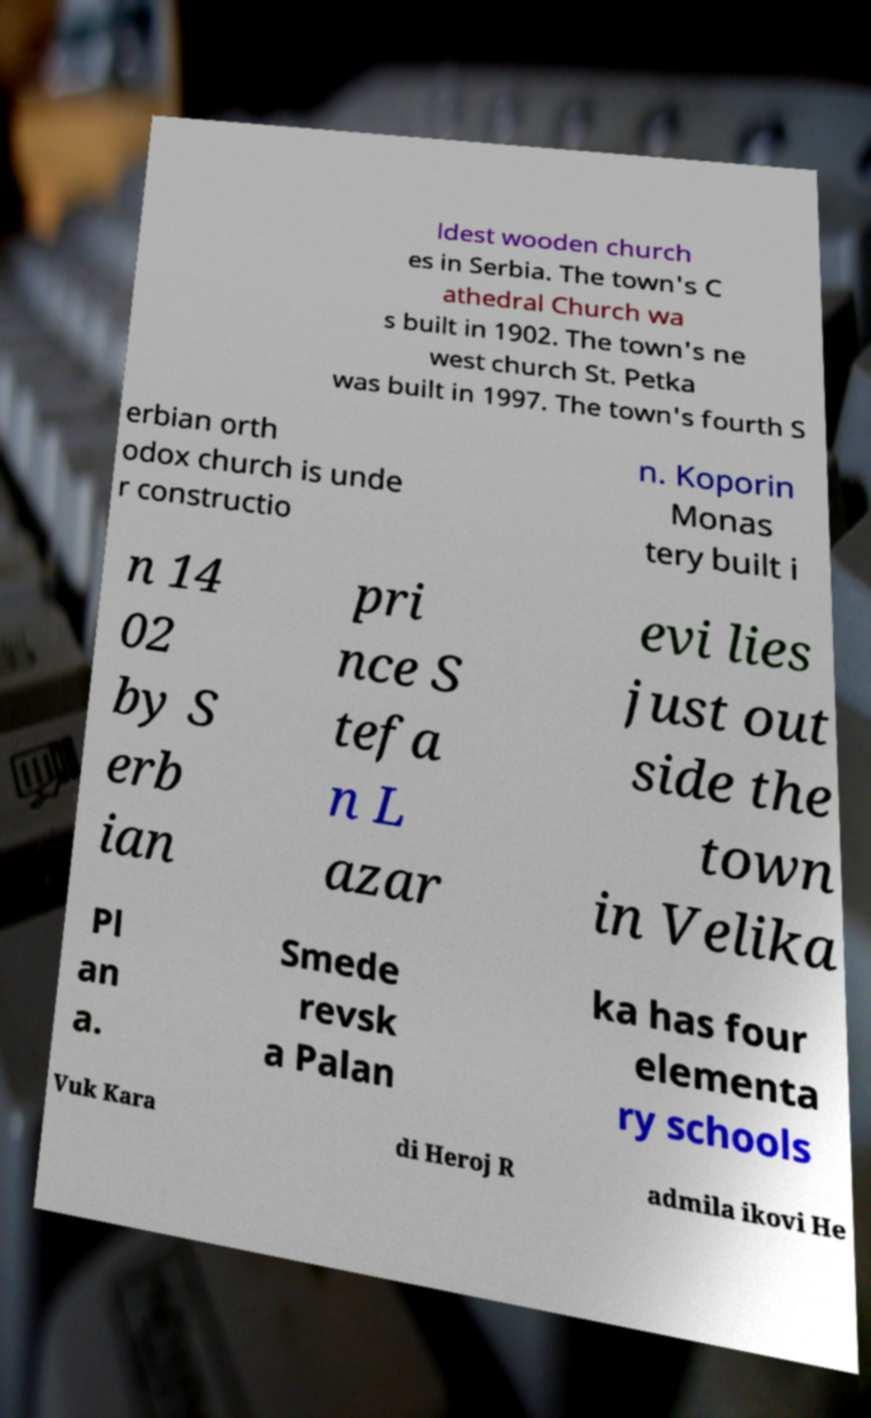Can you accurately transcribe the text from the provided image for me? ldest wooden church es in Serbia. The town's C athedral Church wa s built in 1902. The town's ne west church St. Petka was built in 1997. The town's fourth S erbian orth odox church is unde r constructio n. Koporin Monas tery built i n 14 02 by S erb ian pri nce S tefa n L azar evi lies just out side the town in Velika Pl an a. Smede revsk a Palan ka has four elementa ry schools Vuk Kara di Heroj R admila ikovi He 